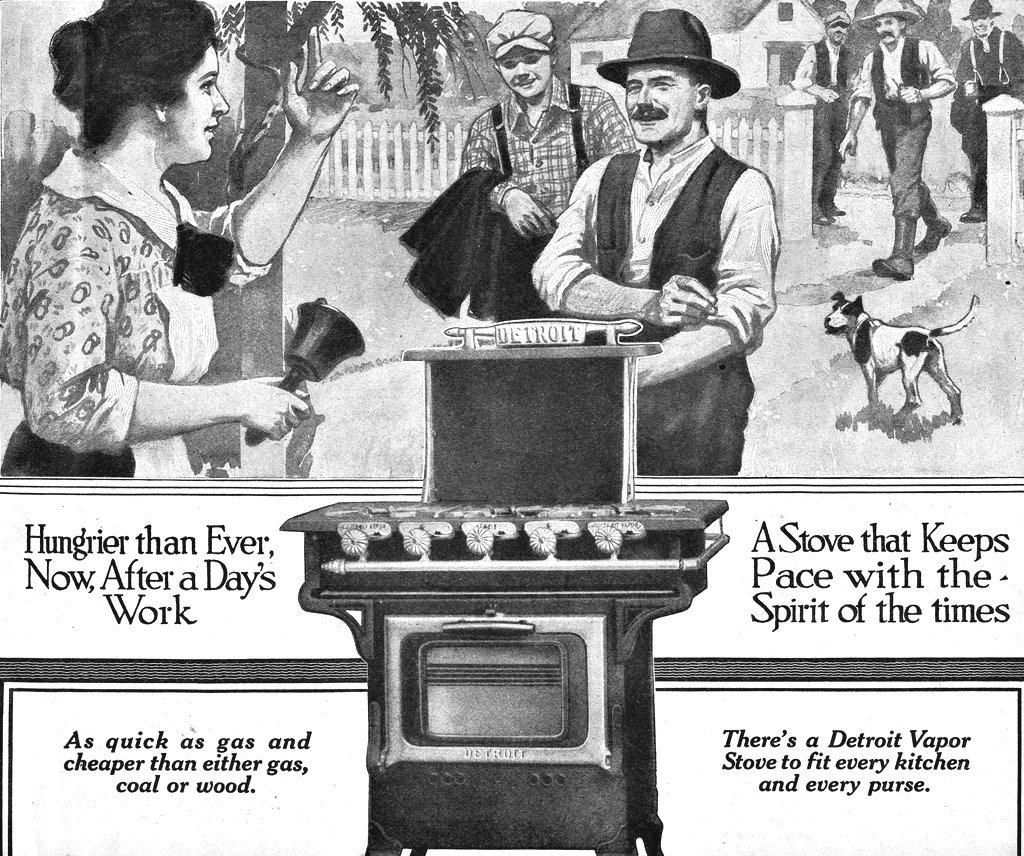Provide a one-sentence caption for the provided image. An advertisement for a stove that says Hungrier than ever, now, after a days work. 